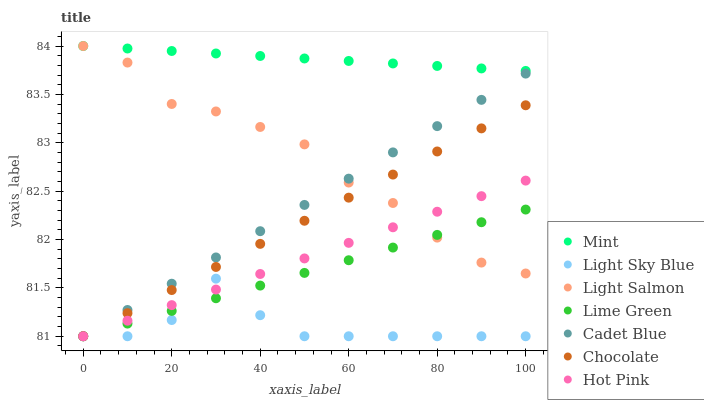Does Light Sky Blue have the minimum area under the curve?
Answer yes or no. Yes. Does Mint have the maximum area under the curve?
Answer yes or no. Yes. Does Cadet Blue have the minimum area under the curve?
Answer yes or no. No. Does Cadet Blue have the maximum area under the curve?
Answer yes or no. No. Is Lime Green the smoothest?
Answer yes or no. Yes. Is Light Sky Blue the roughest?
Answer yes or no. Yes. Is Cadet Blue the smoothest?
Answer yes or no. No. Is Cadet Blue the roughest?
Answer yes or no. No. Does Cadet Blue have the lowest value?
Answer yes or no. Yes. Does Mint have the lowest value?
Answer yes or no. No. Does Mint have the highest value?
Answer yes or no. Yes. Does Cadet Blue have the highest value?
Answer yes or no. No. Is Cadet Blue less than Mint?
Answer yes or no. Yes. Is Mint greater than Chocolate?
Answer yes or no. Yes. Does Cadet Blue intersect Light Salmon?
Answer yes or no. Yes. Is Cadet Blue less than Light Salmon?
Answer yes or no. No. Is Cadet Blue greater than Light Salmon?
Answer yes or no. No. Does Cadet Blue intersect Mint?
Answer yes or no. No. 